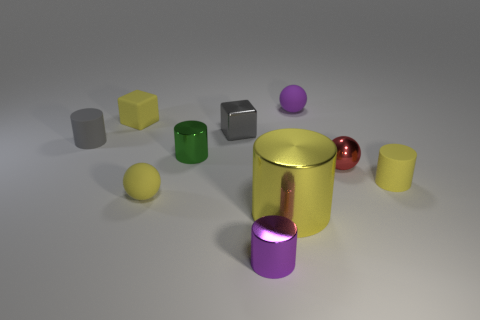Can you tell me what different shapes are present in this image? Certainly! The image contains a variety of geometric shapes including cylinders, spheres, and cubes. And what about the colors available in those shapes? The objects display a vibrant array of colors: yellow, green, red, silver, and shades of purple. 